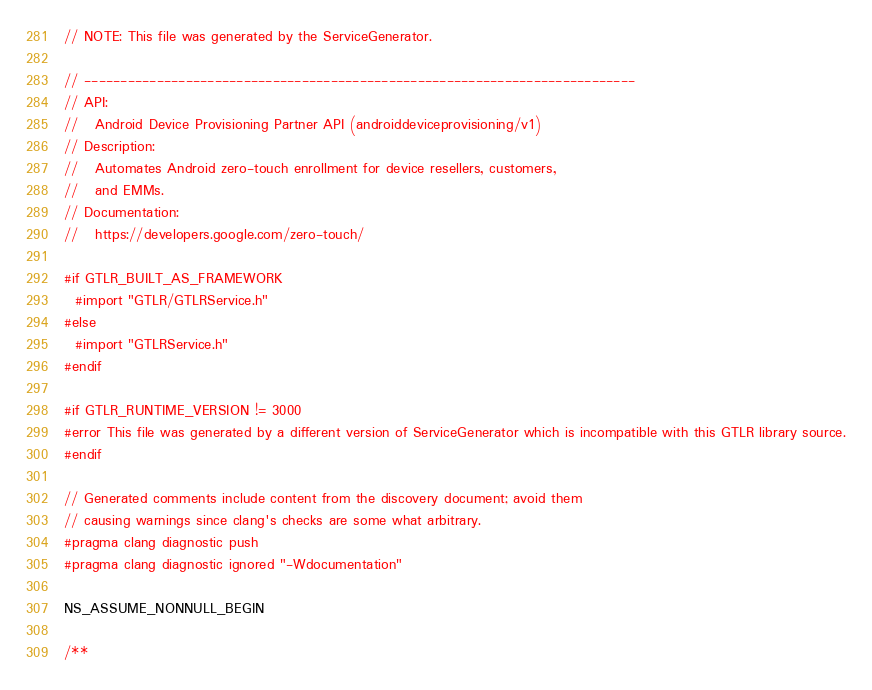<code> <loc_0><loc_0><loc_500><loc_500><_C_>// NOTE: This file was generated by the ServiceGenerator.

// ----------------------------------------------------------------------------
// API:
//   Android Device Provisioning Partner API (androiddeviceprovisioning/v1)
// Description:
//   Automates Android zero-touch enrollment for device resellers, customers,
//   and EMMs.
// Documentation:
//   https://developers.google.com/zero-touch/

#if GTLR_BUILT_AS_FRAMEWORK
  #import "GTLR/GTLRService.h"
#else
  #import "GTLRService.h"
#endif

#if GTLR_RUNTIME_VERSION != 3000
#error This file was generated by a different version of ServiceGenerator which is incompatible with this GTLR library source.
#endif

// Generated comments include content from the discovery document; avoid them
// causing warnings since clang's checks are some what arbitrary.
#pragma clang diagnostic push
#pragma clang diagnostic ignored "-Wdocumentation"

NS_ASSUME_NONNULL_BEGIN

/**</code> 